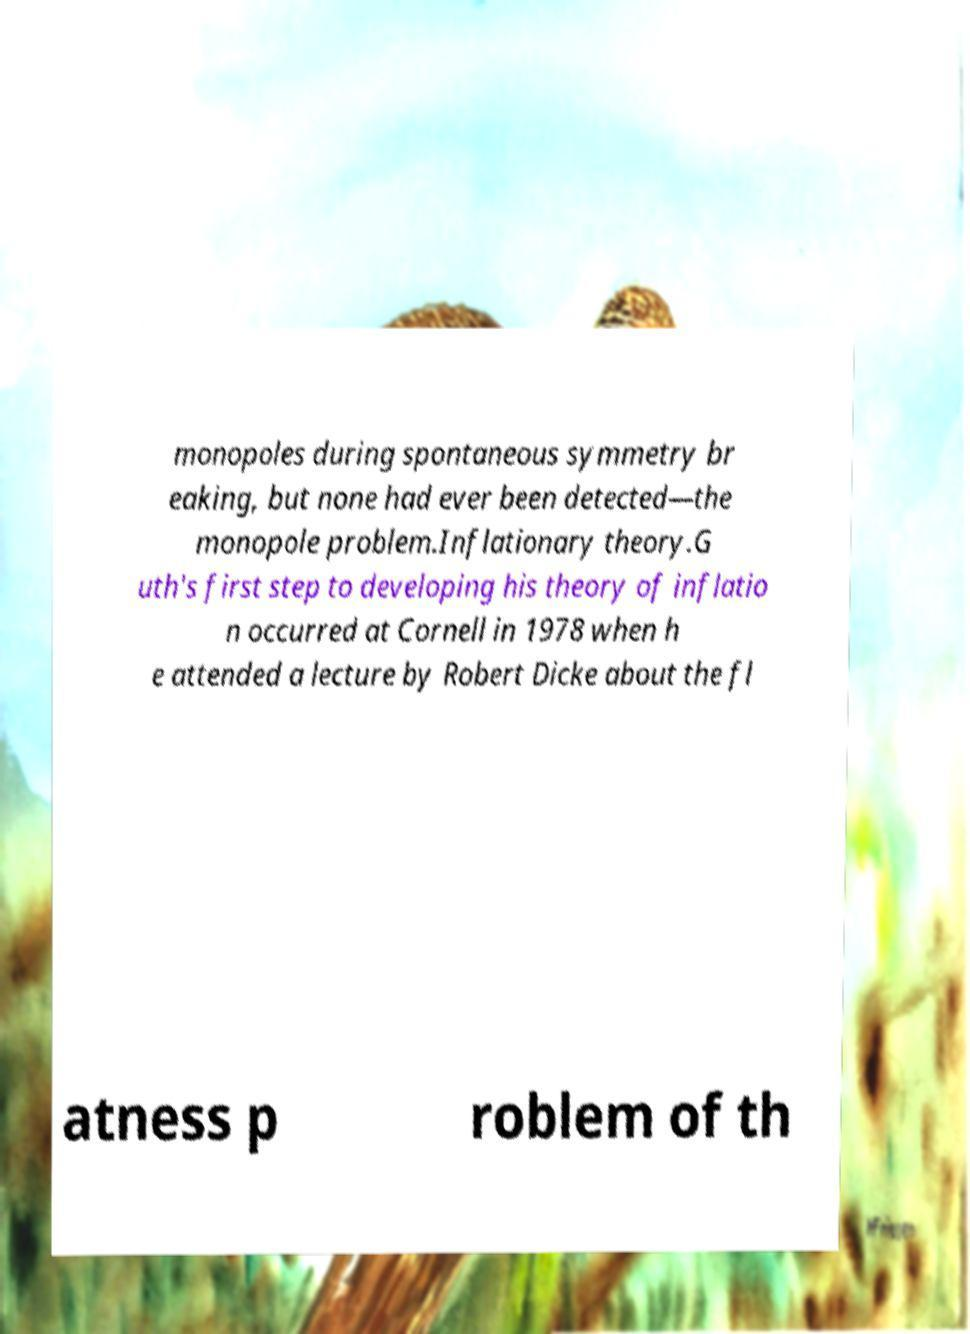Could you assist in decoding the text presented in this image and type it out clearly? monopoles during spontaneous symmetry br eaking, but none had ever been detected—the monopole problem.Inflationary theory.G uth's first step to developing his theory of inflatio n occurred at Cornell in 1978 when h e attended a lecture by Robert Dicke about the fl atness p roblem of th 